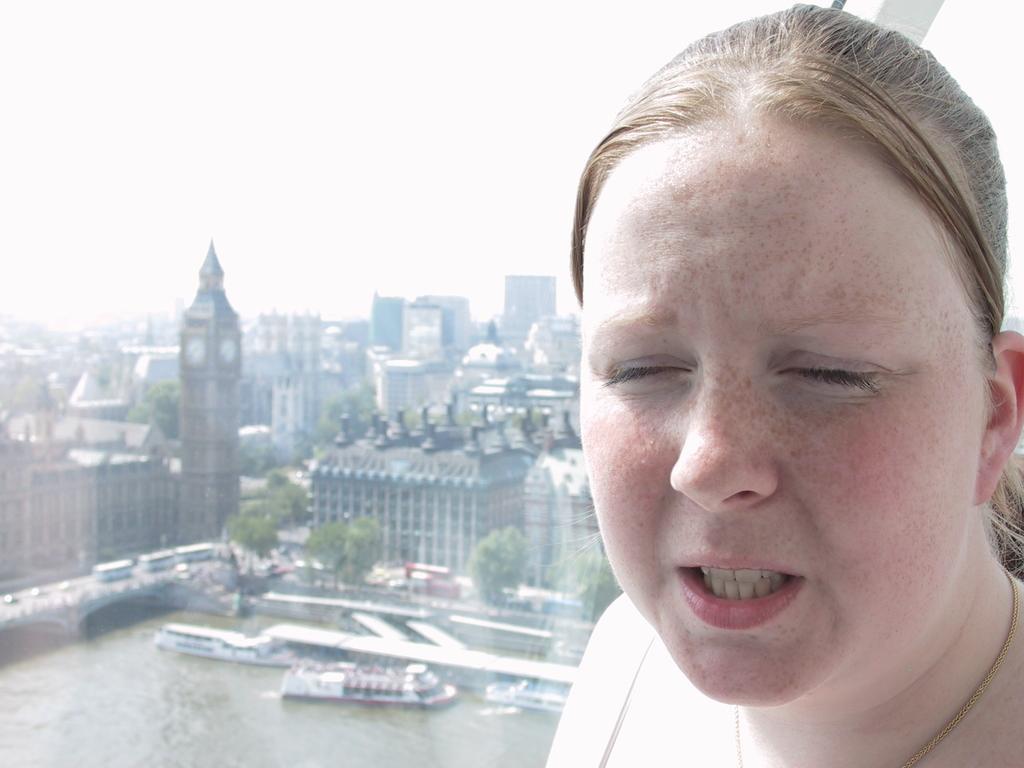In one or two sentences, can you explain what this image depicts? In this image we can see a person's face. In the background of the image there are buildings, ships, vehicles, trees, water and other objects. On the left side top of the image there is the sky. 